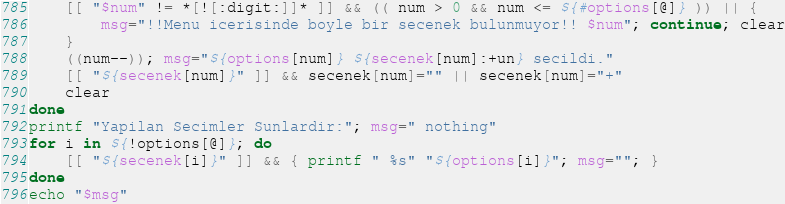<code> <loc_0><loc_0><loc_500><loc_500><_Bash_>    [[ "$num" != *[![:digit:]]* ]] && (( num > 0 && num <= ${#options[@]} )) || {
        msg="!!Menu icerisinde boyle bir secenek bulunmuyor!! $num"; continue; clear
    }
    ((num--)); msg="${options[num]} ${secenek[num]:+un} secildi."
    [[ "${secenek[num]}" ]] && secenek[num]="" || secenek[num]="+"
	clear
done
printf "Yapilan Secimler Sunlardir:"; msg=" nothing"
for i in ${!options[@]}; do 
    [[ "${secenek[i]}" ]] && { printf " %s" "${options[i]}"; msg=""; }
done
echo "$msg"
</code> 